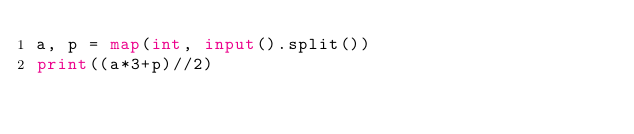<code> <loc_0><loc_0><loc_500><loc_500><_Python_>a, p = map(int, input().split())
print((a*3+p)//2)</code> 